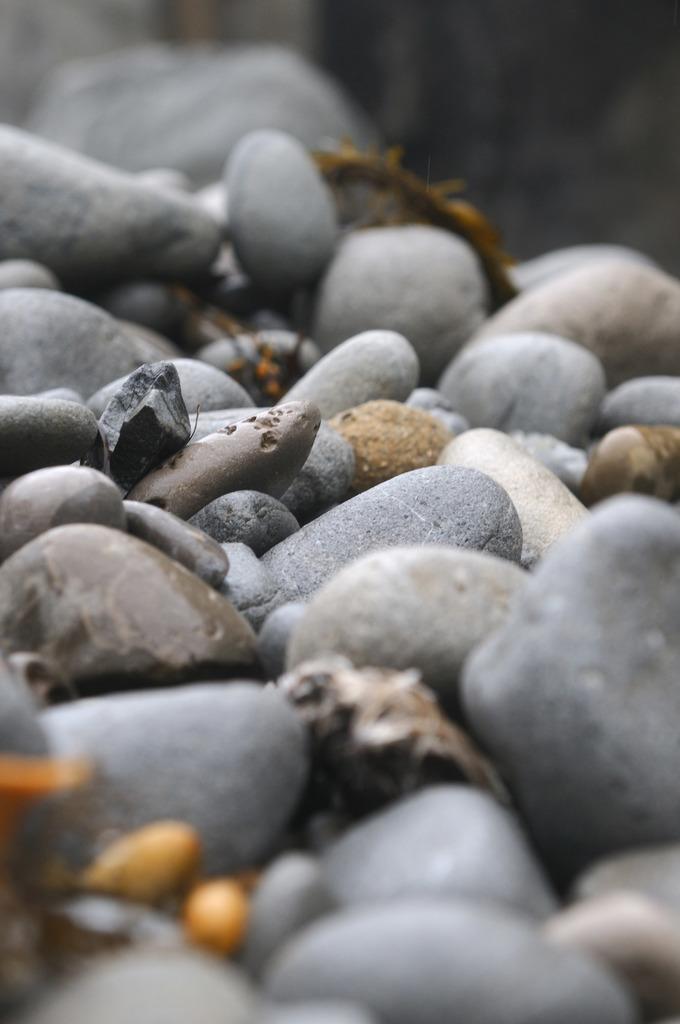Describe this image in one or two sentences. The picture consists of pebble stones. At the top and at the bottom it is blurred. 